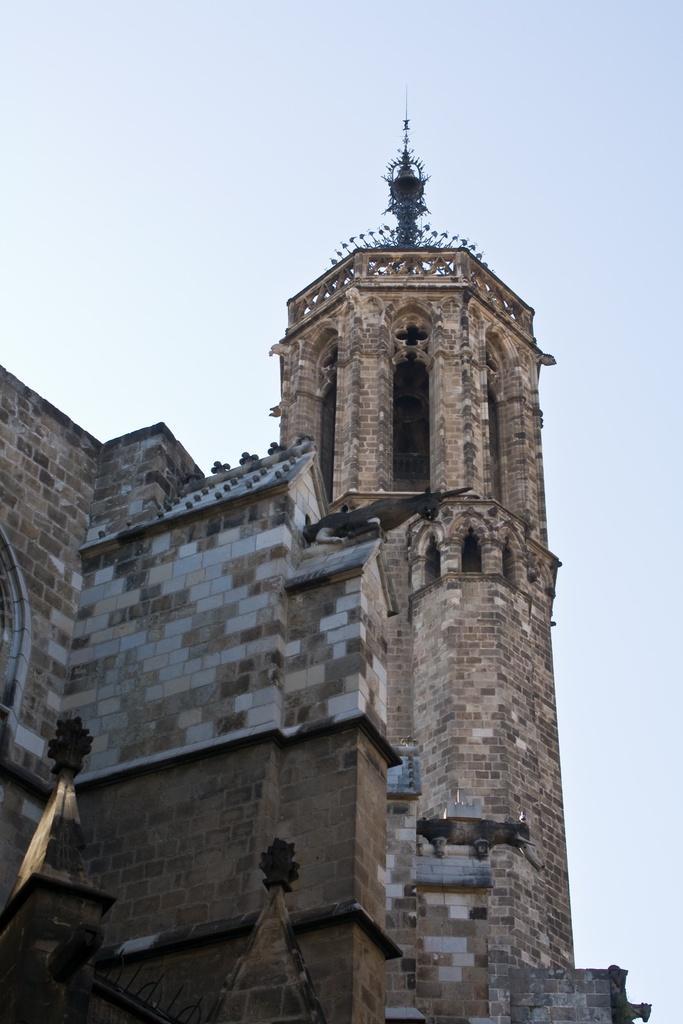Could you give a brief overview of what you see in this image? In this picture in the front there is a castle and at the top there is sky. 